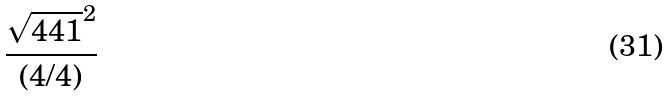<formula> <loc_0><loc_0><loc_500><loc_500>\frac { \sqrt { 4 4 1 } ^ { 2 } } { ( 4 / 4 ) }</formula> 